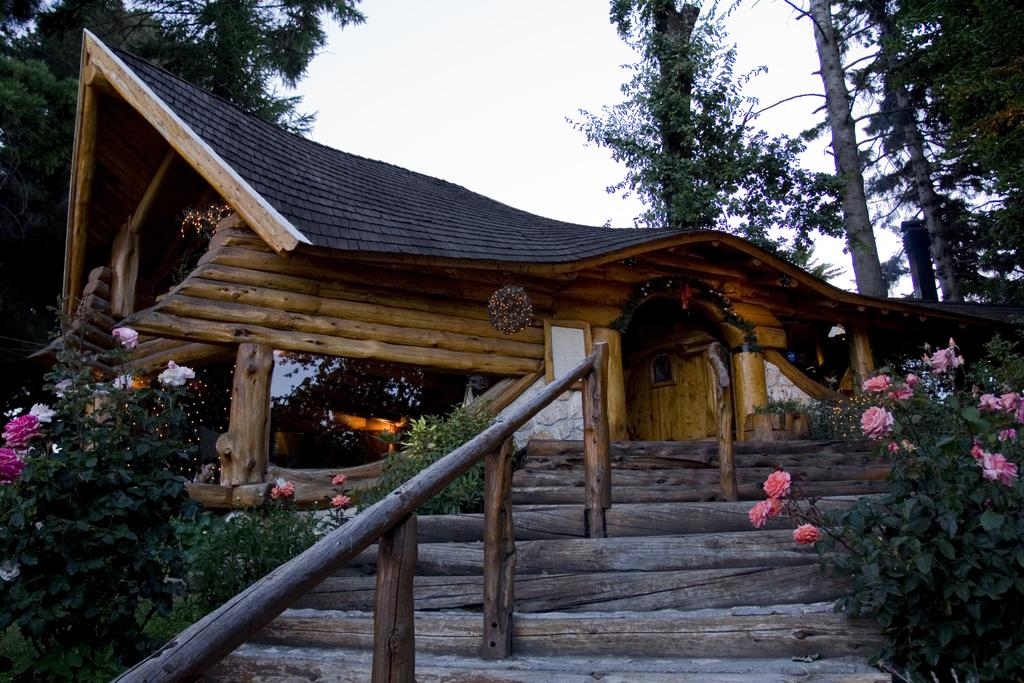What type of living organisms can be seen in the image? Plants and flowers are visible in the image. What type of structure is present in the image? There is a house in the image. What other natural elements can be seen in the image? Trees are present in the image. What is visible in the background of the image? The sky is visible in the background of the image. What type of screw can be seen holding the dress on the train in the image? There is no screw, dress, or train present in the image. 